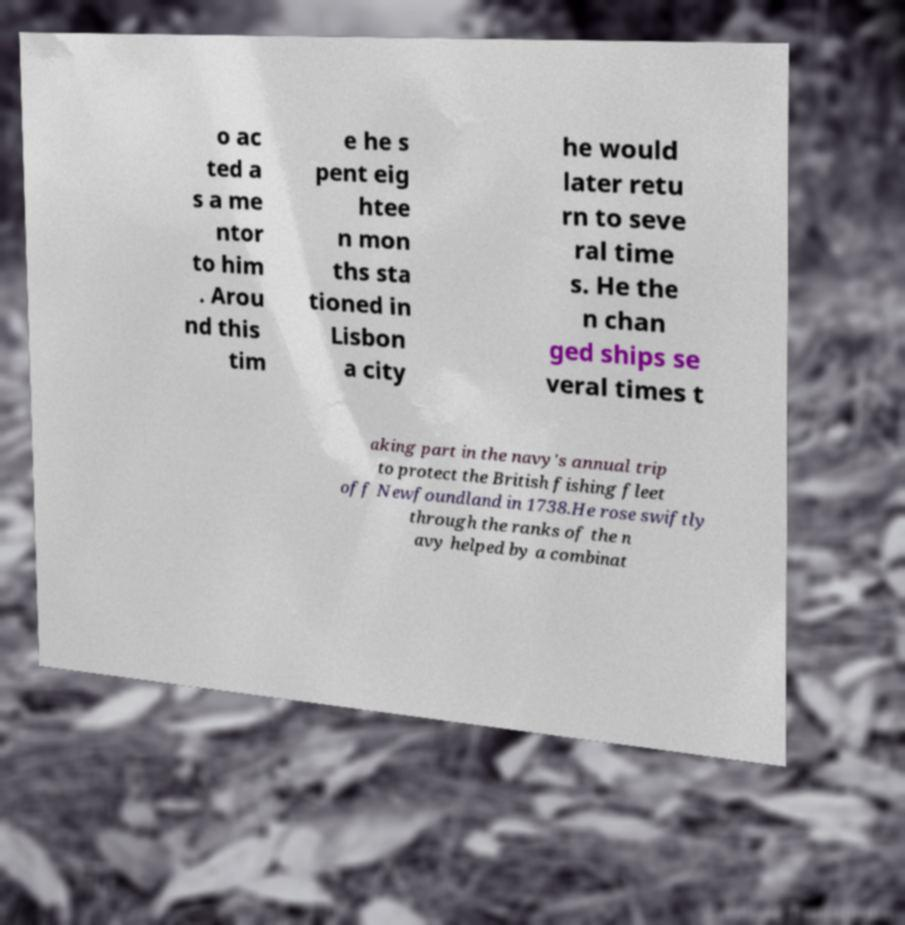What messages or text are displayed in this image? I need them in a readable, typed format. o ac ted a s a me ntor to him . Arou nd this tim e he s pent eig htee n mon ths sta tioned in Lisbon a city he would later retu rn to seve ral time s. He the n chan ged ships se veral times t aking part in the navy's annual trip to protect the British fishing fleet off Newfoundland in 1738.He rose swiftly through the ranks of the n avy helped by a combinat 